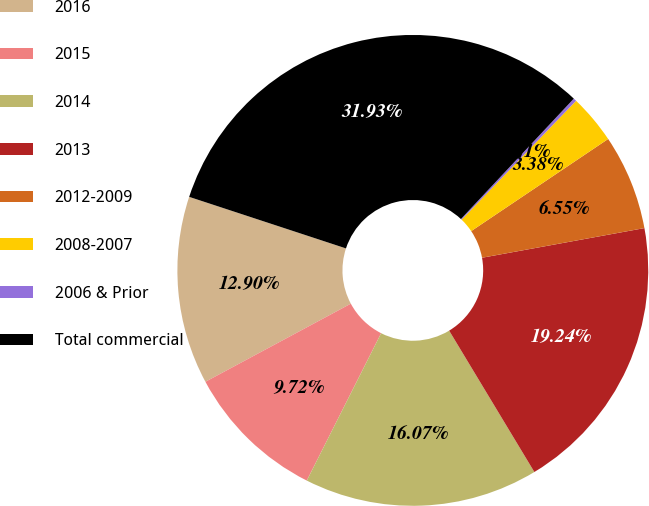Convert chart to OTSL. <chart><loc_0><loc_0><loc_500><loc_500><pie_chart><fcel>2016<fcel>2015<fcel>2014<fcel>2013<fcel>2012-2009<fcel>2008-2007<fcel>2006 & Prior<fcel>Total commercial<nl><fcel>12.9%<fcel>9.72%<fcel>16.07%<fcel>19.24%<fcel>6.55%<fcel>3.38%<fcel>0.21%<fcel>31.93%<nl></chart> 